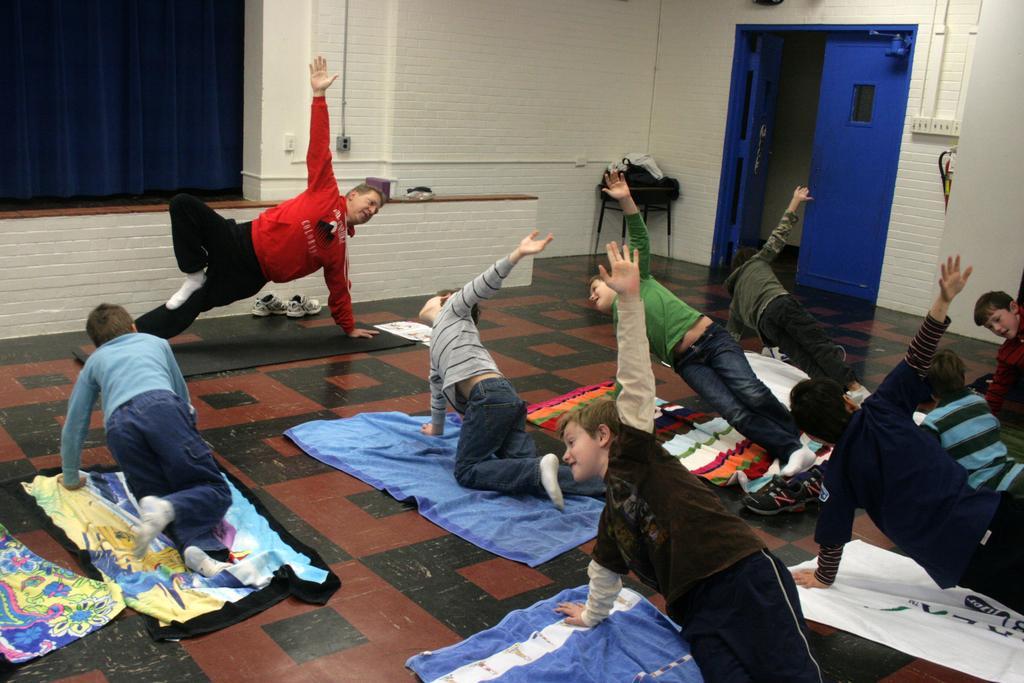Describe this image in one or two sentences. In this image we can see a few people doing yoga on yoga mats, also we can see doors, stool with some objects on it, a curtain and the wall. 